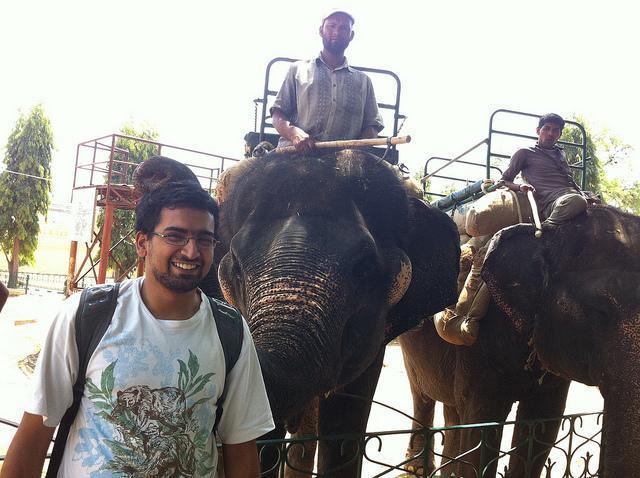How many elephants are in the photo?
Give a very brief answer. 2. How many people are there?
Give a very brief answer. 3. How many grey bears are in the picture?
Give a very brief answer. 0. 